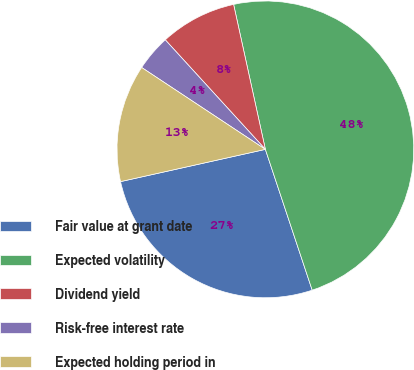Convert chart. <chart><loc_0><loc_0><loc_500><loc_500><pie_chart><fcel>Fair value at grant date<fcel>Expected volatility<fcel>Dividend yield<fcel>Risk-free interest rate<fcel>Expected holding period in<nl><fcel>26.62%<fcel>48.32%<fcel>8.35%<fcel>3.91%<fcel>12.79%<nl></chart> 